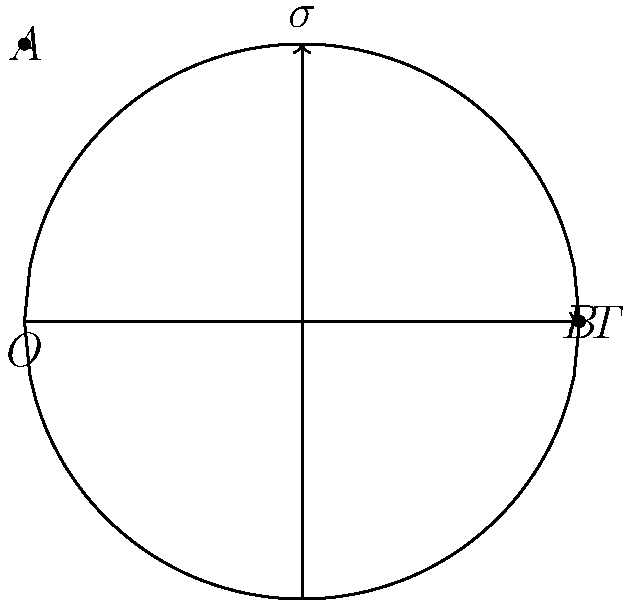As a fan of CSNY, you know that Stephen Stills is renowned for his guitar skills. Consider a guitar string under tension T, represented by the curved line OAB in the diagram. If the string has a circular profile with radius r and the maximum stress occurs at point A, express the maximum stress $\sigma_{max}$ in terms of T and r. Let's approach this step-by-step:

1) In a curved beam (like our guitar string), the stress distribution is not uniform. The maximum stress occurs at the point furthest from the neutral axis, which in this case is point A.

2) For a circular profile, we can use the equation for stress in a curved beam:

   $$\sigma = \frac{T}{A} + \frac{My}{I}$$

   where T is the tension, A is the cross-sectional area, M is the bending moment, y is the distance from the neutral axis, and I is the moment of inertia.

3) At point A, y = r (the radius of the circular profile).

4) For a circular cross-section, A = $\pi r^2$ and I = $\frac{\pi r^4}{4}$.

5) The bending moment M at any point is given by M = Tr.

6) Substituting these into our stress equation:

   $$\sigma_{max} = \frac{T}{\pi r^2} + \frac{Tr^2}{\frac{\pi r^4}{4}} \cdot r$$

7) Simplifying:

   $$\sigma_{max} = \frac{T}{\pi r^2} + \frac{4T}{\pi r^2}$$

8) Further simplification:

   $$\sigma_{max} = \frac{5T}{\pi r^2}$$

This gives us the maximum stress in terms of T and r.
Answer: $\sigma_{max} = \frac{5T}{\pi r^2}$ 